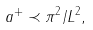Convert formula to latex. <formula><loc_0><loc_0><loc_500><loc_500>a ^ { + } \prec \pi ^ { 2 } / L ^ { 2 } ,</formula> 